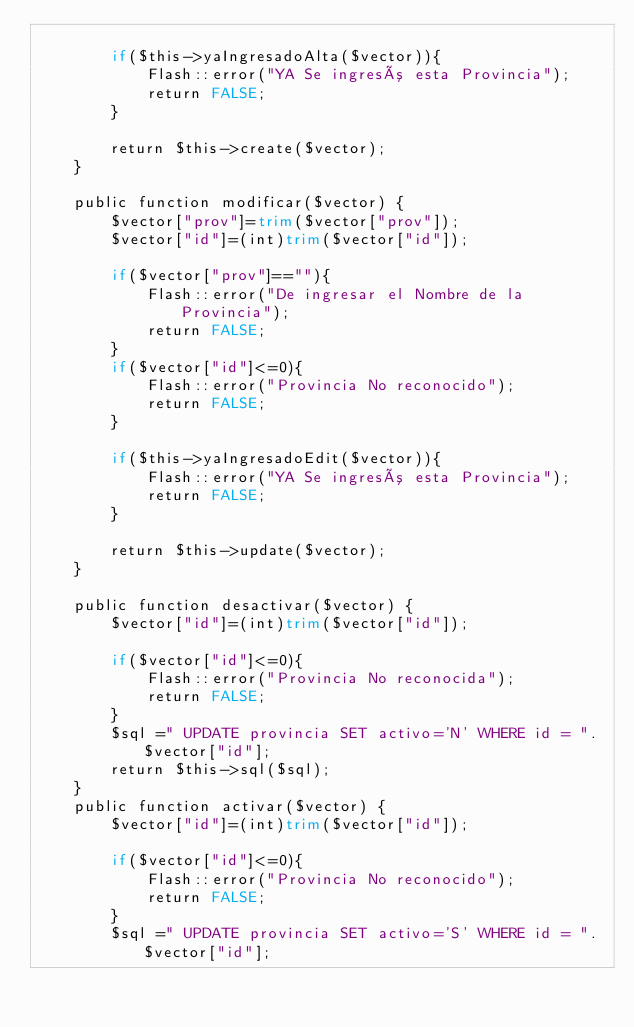<code> <loc_0><loc_0><loc_500><loc_500><_PHP_>        
        if($this->yaIngresadoAlta($vector)){
            Flash::error("YA Se ingresó esta Provincia");
            return FALSE;
        }
        
        return $this->create($vector);
    }
    
    public function modificar($vector) {
        $vector["prov"]=trim($vector["prov"]);
        $vector["id"]=(int)trim($vector["id"]);
        
        if($vector["prov"]==""){
            Flash::error("De ingresar el Nombre de la Provincia");
            return FALSE;
        }
        if($vector["id"]<=0){
            Flash::error("Provincia No reconocido");
            return FALSE;
        }
        
        if($this->yaIngresadoEdit($vector)){
            Flash::error("YA Se ingresó esta Provincia");
            return FALSE;
        }
        
        return $this->update($vector);
    }
    
    public function desactivar($vector) {
        $vector["id"]=(int)trim($vector["id"]);
        
        if($vector["id"]<=0){
            Flash::error("Provincia No reconocida");
            return FALSE;
        }
        $sql =" UPDATE provincia SET activo='N' WHERE id = ".$vector["id"];
        return $this->sql($sql);
    }
    public function activar($vector) {
        $vector["id"]=(int)trim($vector["id"]);
        
        if($vector["id"]<=0){
            Flash::error("Provincia No reconocido");
            return FALSE;
        }
        $sql =" UPDATE provincia SET activo='S' WHERE id = ".$vector["id"];</code> 